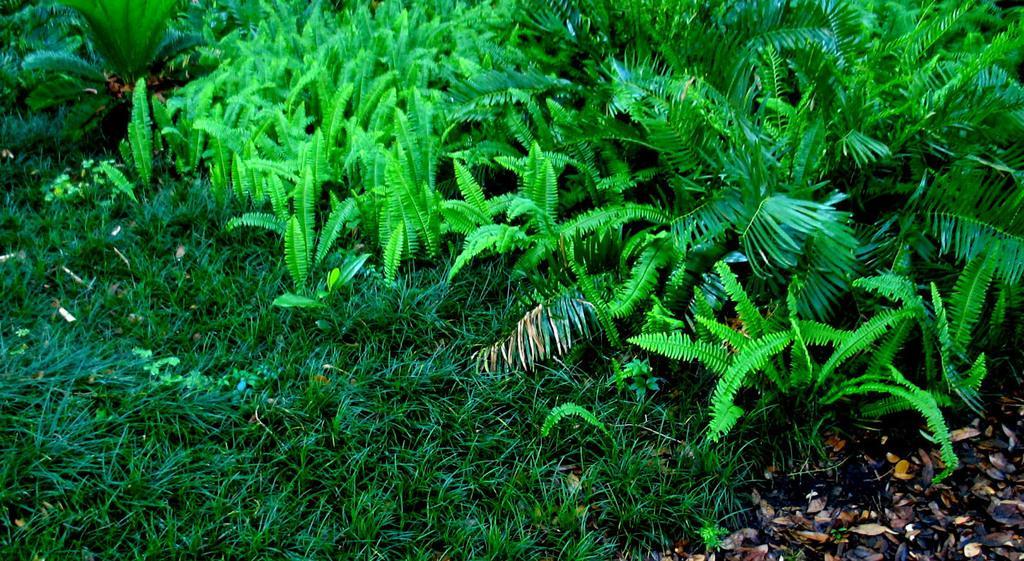Describe this image in one or two sentences. In this picture I can observe some grass on the land. There are green color plants. I can observe some dried leaves on the right side. 